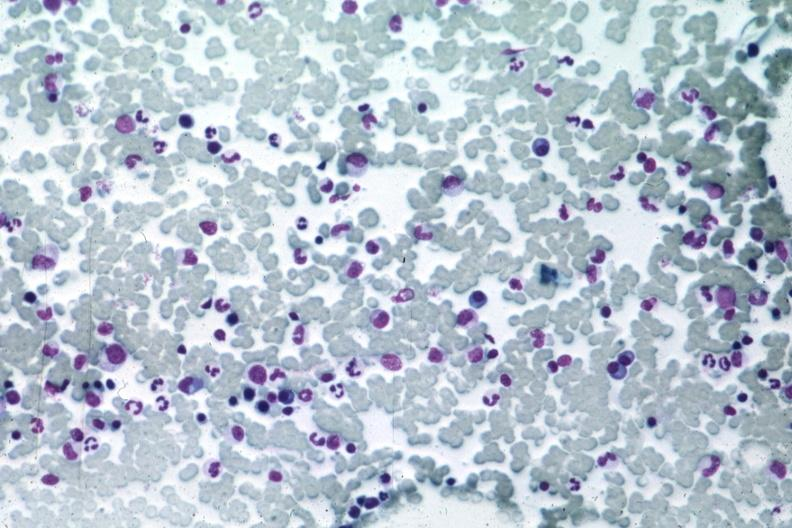does glioma show med many atypical plasma cells easily seen?
Answer the question using a single word or phrase. No 